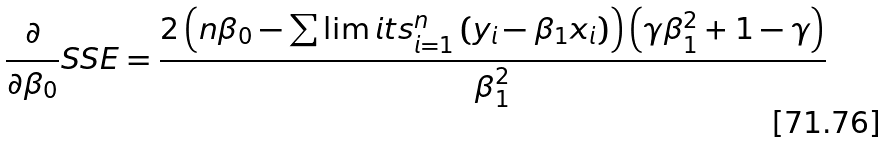Convert formula to latex. <formula><loc_0><loc_0><loc_500><loc_500>\frac { \partial } { \partial \beta _ { 0 } } S S E = \frac { 2 \left ( n \beta _ { 0 } - \sum \lim i t s _ { i = 1 } ^ { n } \left ( y _ { i } - \beta _ { 1 } x _ { i } \right ) \right ) \left ( \gamma \beta _ { 1 } ^ { 2 } + 1 - \gamma \right ) } { \beta _ { 1 } ^ { 2 } }</formula> 